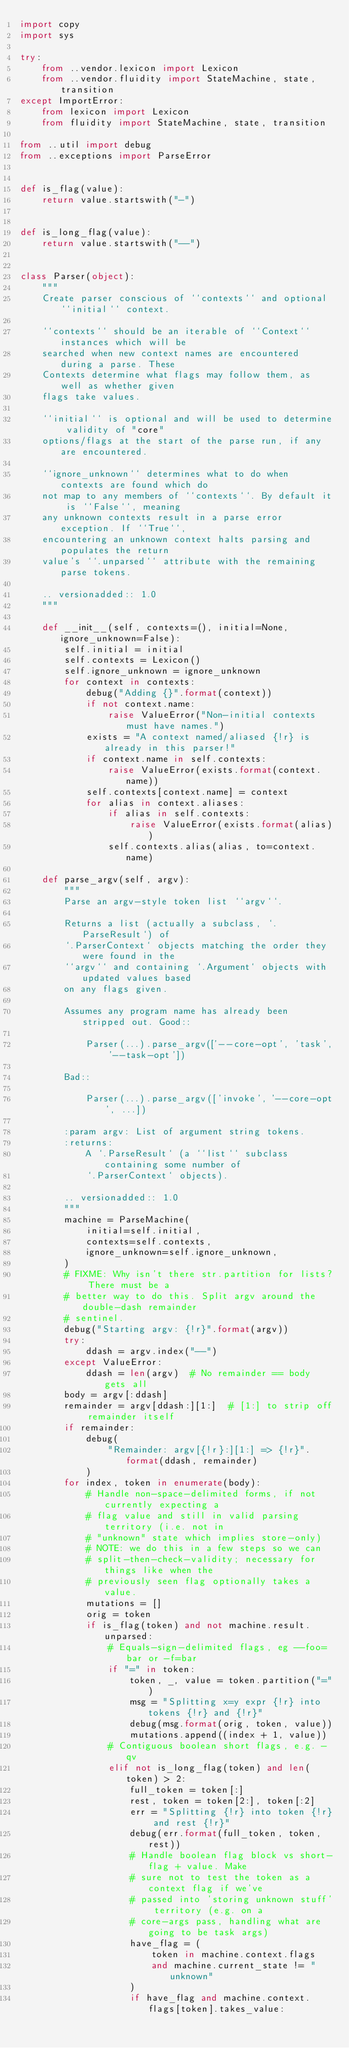Convert code to text. <code><loc_0><loc_0><loc_500><loc_500><_Python_>import copy
import sys

try:
    from ..vendor.lexicon import Lexicon
    from ..vendor.fluidity import StateMachine, state, transition
except ImportError:
    from lexicon import Lexicon
    from fluidity import StateMachine, state, transition

from ..util import debug
from ..exceptions import ParseError


def is_flag(value):
    return value.startswith("-")


def is_long_flag(value):
    return value.startswith("--")


class Parser(object):
    """
    Create parser conscious of ``contexts`` and optional ``initial`` context.

    ``contexts`` should be an iterable of ``Context`` instances which will be
    searched when new context names are encountered during a parse. These
    Contexts determine what flags may follow them, as well as whether given
    flags take values.

    ``initial`` is optional and will be used to determine validity of "core"
    options/flags at the start of the parse run, if any are encountered.

    ``ignore_unknown`` determines what to do when contexts are found which do
    not map to any members of ``contexts``. By default it is ``False``, meaning
    any unknown contexts result in a parse error exception. If ``True``,
    encountering an unknown context halts parsing and populates the return
    value's ``.unparsed`` attribute with the remaining parse tokens.

    .. versionadded:: 1.0
    """

    def __init__(self, contexts=(), initial=None, ignore_unknown=False):
        self.initial = initial
        self.contexts = Lexicon()
        self.ignore_unknown = ignore_unknown
        for context in contexts:
            debug("Adding {}".format(context))
            if not context.name:
                raise ValueError("Non-initial contexts must have names.")
            exists = "A context named/aliased {!r} is already in this parser!"
            if context.name in self.contexts:
                raise ValueError(exists.format(context.name))
            self.contexts[context.name] = context
            for alias in context.aliases:
                if alias in self.contexts:
                    raise ValueError(exists.format(alias))
                self.contexts.alias(alias, to=context.name)

    def parse_argv(self, argv):
        """
        Parse an argv-style token list ``argv``.

        Returns a list (actually a subclass, `.ParseResult`) of
        `.ParserContext` objects matching the order they were found in the
        ``argv`` and containing `.Argument` objects with updated values based
        on any flags given.

        Assumes any program name has already been stripped out. Good::

            Parser(...).parse_argv(['--core-opt', 'task', '--task-opt'])

        Bad::

            Parser(...).parse_argv(['invoke', '--core-opt', ...])

        :param argv: List of argument string tokens.
        :returns:
            A `.ParseResult` (a ``list`` subclass containing some number of
            `.ParserContext` objects).

        .. versionadded:: 1.0
        """
        machine = ParseMachine(
            initial=self.initial,
            contexts=self.contexts,
            ignore_unknown=self.ignore_unknown,
        )
        # FIXME: Why isn't there str.partition for lists? There must be a
        # better way to do this. Split argv around the double-dash remainder
        # sentinel.
        debug("Starting argv: {!r}".format(argv))
        try:
            ddash = argv.index("--")
        except ValueError:
            ddash = len(argv)  # No remainder == body gets all
        body = argv[:ddash]
        remainder = argv[ddash:][1:]  # [1:] to strip off remainder itself
        if remainder:
            debug(
                "Remainder: argv[{!r}:][1:] => {!r}".format(ddash, remainder)
            )
        for index, token in enumerate(body):
            # Handle non-space-delimited forms, if not currently expecting a
            # flag value and still in valid parsing territory (i.e. not in
            # "unknown" state which implies store-only)
            # NOTE: we do this in a few steps so we can
            # split-then-check-validity; necessary for things like when the
            # previously seen flag optionally takes a value.
            mutations = []
            orig = token
            if is_flag(token) and not machine.result.unparsed:
                # Equals-sign-delimited flags, eg --foo=bar or -f=bar
                if "=" in token:
                    token, _, value = token.partition("=")
                    msg = "Splitting x=y expr {!r} into tokens {!r} and {!r}"
                    debug(msg.format(orig, token, value))
                    mutations.append((index + 1, value))
                # Contiguous boolean short flags, e.g. -qv
                elif not is_long_flag(token) and len(token) > 2:
                    full_token = token[:]
                    rest, token = token[2:], token[:2]
                    err = "Splitting {!r} into token {!r} and rest {!r}"
                    debug(err.format(full_token, token, rest))
                    # Handle boolean flag block vs short-flag + value. Make
                    # sure not to test the token as a context flag if we've
                    # passed into 'storing unknown stuff' territory (e.g. on a
                    # core-args pass, handling what are going to be task args)
                    have_flag = (
                        token in machine.context.flags
                        and machine.current_state != "unknown"
                    )
                    if have_flag and machine.context.flags[token].takes_value:</code> 